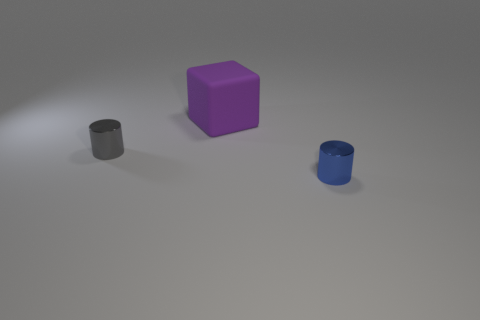There is a tiny blue metallic object; is it the same shape as the shiny object on the left side of the large purple thing?
Your answer should be compact. Yes. How many objects are either things in front of the large rubber thing or large yellow rubber cubes?
Ensure brevity in your answer.  2. Is there anything else that has the same material as the purple cube?
Provide a short and direct response. No. What number of objects are both in front of the purple cube and behind the blue thing?
Keep it short and to the point. 1. How many things are tiny cylinders left of the purple block or metal cylinders that are behind the tiny blue metal cylinder?
Offer a very short reply. 1. What number of other objects are there of the same shape as the tiny gray shiny thing?
Make the answer very short. 1. Do the metal object that is on the left side of the purple rubber thing and the matte thing have the same color?
Keep it short and to the point. No. How many other objects are there of the same size as the gray cylinder?
Provide a short and direct response. 1. Are the small gray cylinder and the blue cylinder made of the same material?
Your answer should be compact. Yes. What color is the metallic cylinder that is in front of the shiny cylinder on the left side of the rubber cube?
Ensure brevity in your answer.  Blue. 